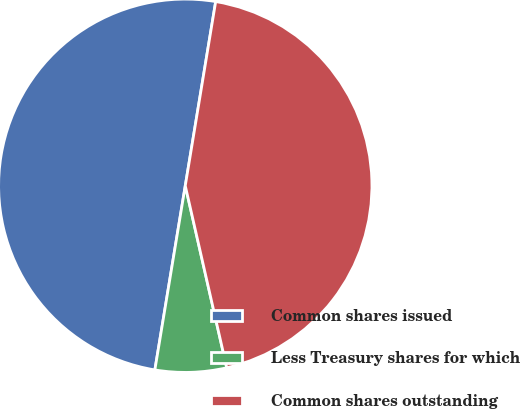Convert chart. <chart><loc_0><loc_0><loc_500><loc_500><pie_chart><fcel>Common shares issued<fcel>Less Treasury shares for which<fcel>Common shares outstanding<nl><fcel>50.0%<fcel>6.17%<fcel>43.83%<nl></chart> 